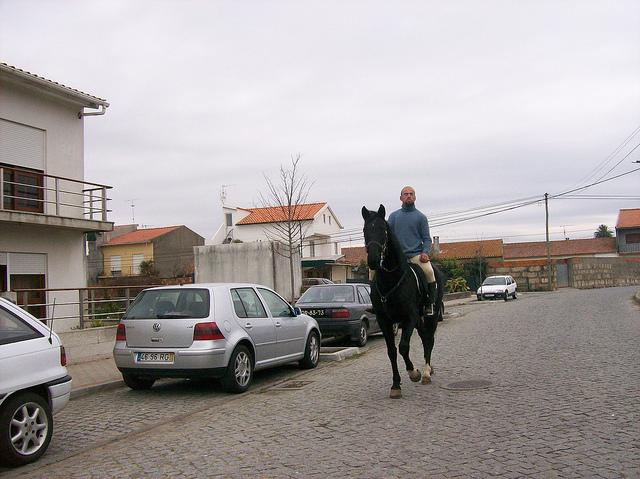What is he doing with the horse?

Choices:
A) riding it
B) stealing it
C) feeding it
D) mounting it riding it 